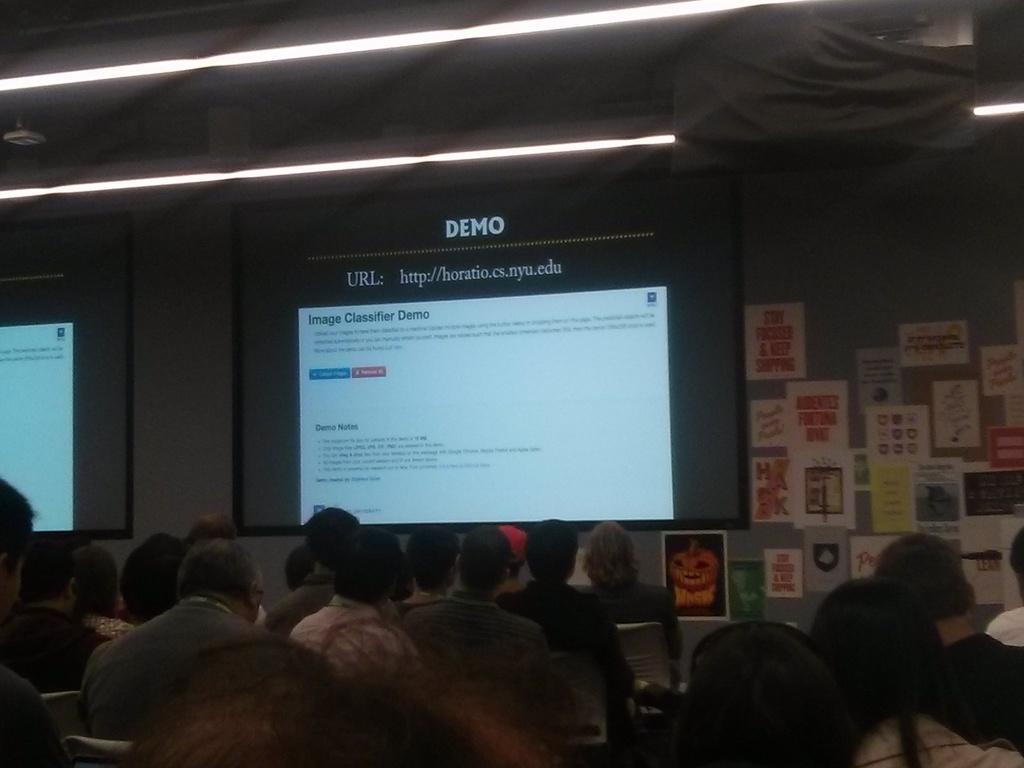Could you give a brief overview of what you see in this image? In this picture I can see people sitting on the chairs. I can see the projector. I can see projector screen. I can see posts on the wall on the right side. 